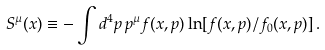Convert formula to latex. <formula><loc_0><loc_0><loc_500><loc_500>S ^ { \mu } ( x ) \equiv - \int d ^ { 4 } p \, p ^ { \mu } f ( x , p ) \ln [ f ( x , p ) / f _ { 0 } ( x , p ) ] \, .</formula> 